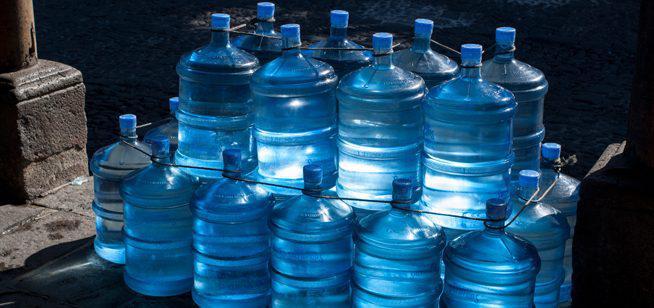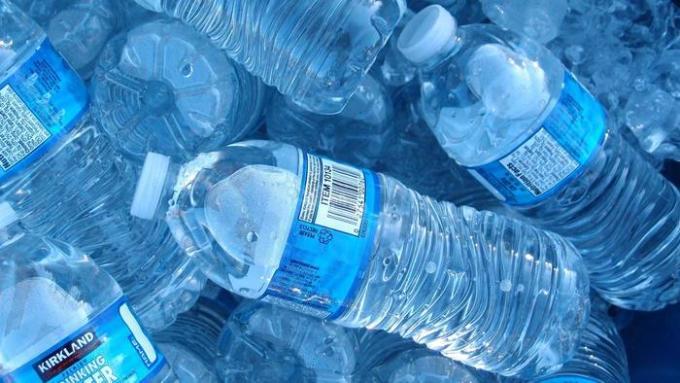The first image is the image on the left, the second image is the image on the right. Analyze the images presented: Is the assertion "An image shows barrel-shaped multi-gallon water jugs with blue lids that don't have a handle." valid? Answer yes or no. Yes. The first image is the image on the left, the second image is the image on the right. Analyze the images presented: Is the assertion "The bottles in one of the images are for water coolers" valid? Answer yes or no. Yes. 